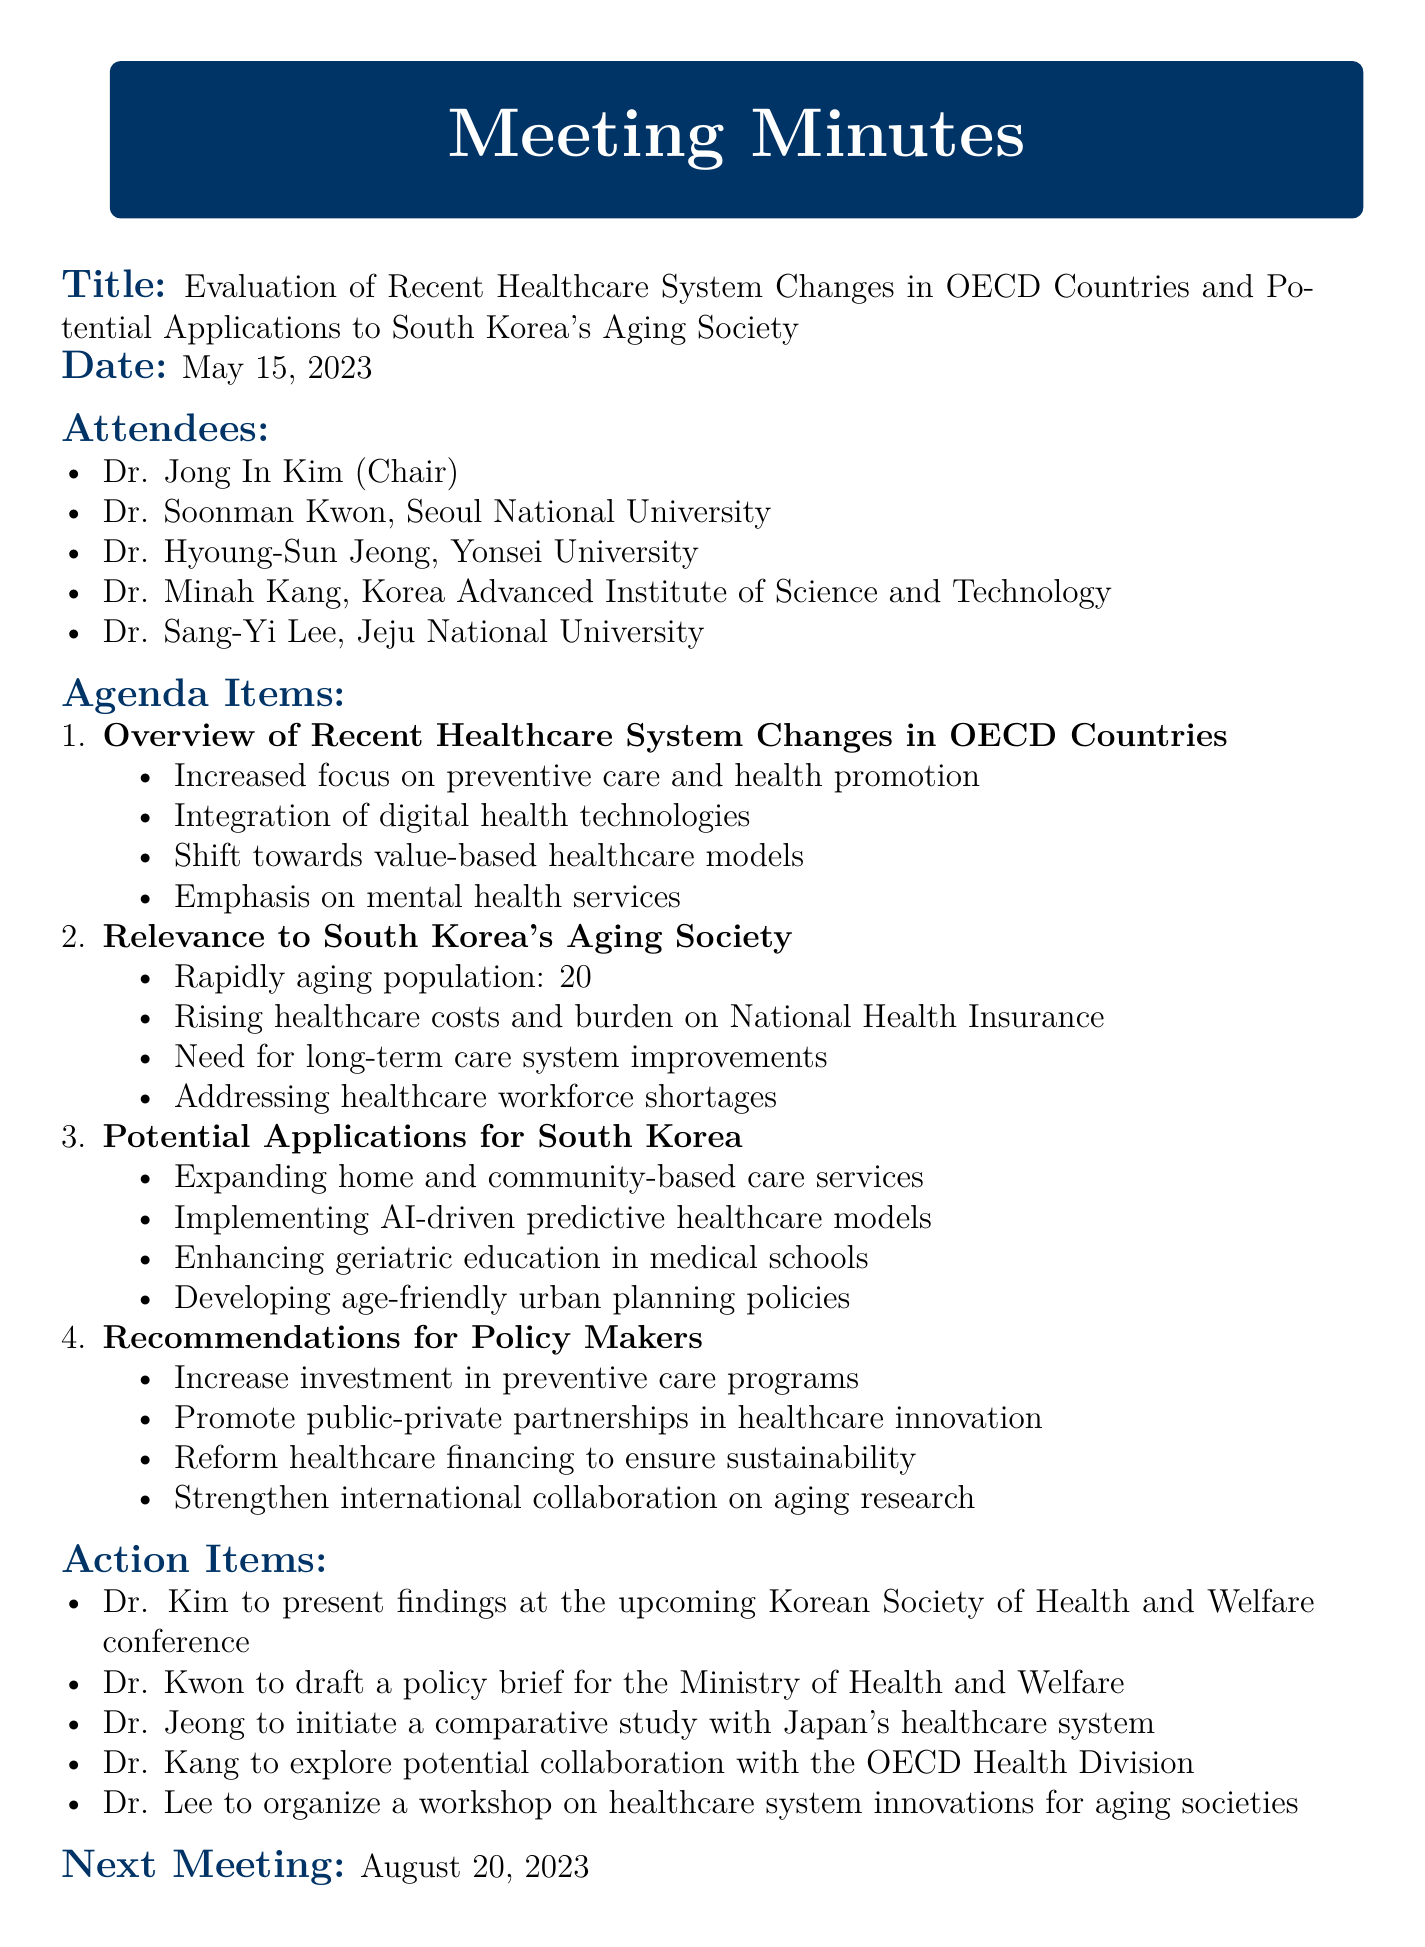What was the meeting date? The meeting date is explicitly stated in the document as May 15, 2023.
Answer: May 15, 2023 Who chaired the meeting? The document identifies Dr. Jong In Kim as the Chair, who is listed among the attendees.
Answer: Dr. Jong In Kim What percentage of the population will be aged 65 and over by 2025 in South Korea? The document mentions that 20% of the population will be aged 65+ by 2025.
Answer: 20% What is one of the key points discussed regarding the relevance to South Korea's aging society? The document lists healthcare costs and workforce shortages as significant issues related to the aging population.
Answer: Rising healthcare costs Which action item involves Dr. Kwon? Dr. Kwon's specific task as an action item is outlined in the document.
Answer: Draft a policy brief for the Ministry of Health and Welfare What is one recommendation for policymakers? The document lists several, including the need to reform healthcare financing to ensure sustainability.
Answer: Reform healthcare financing How many attendees were present at the meeting? The number of attendees can be counted from the list provided in the document.
Answer: Five What does the next meeting date indicate? The document calls attention to the scheduling of the next meeting, being August 20, 2023.
Answer: August 20, 2023 